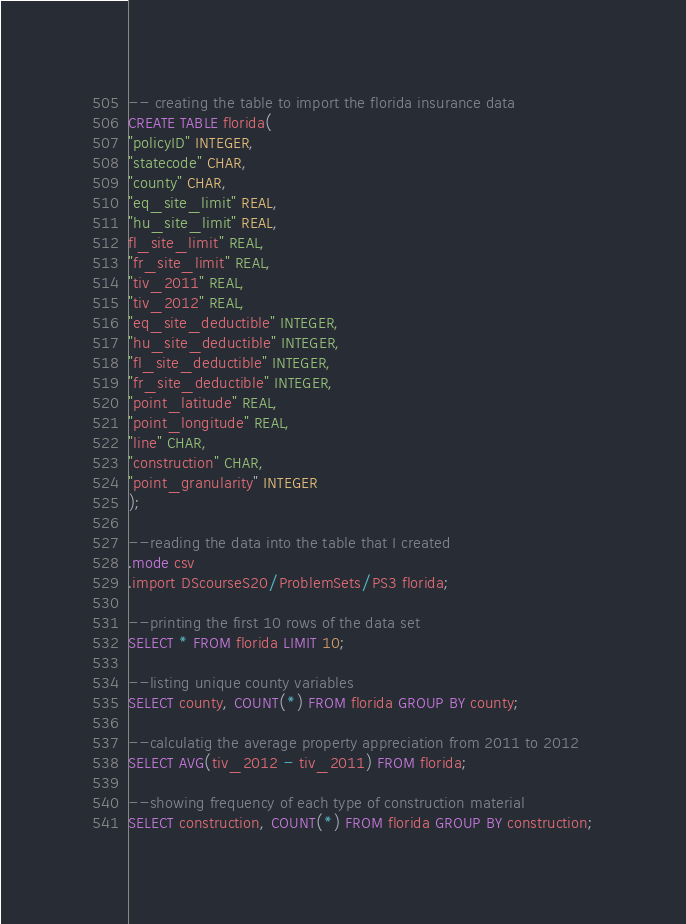<code> <loc_0><loc_0><loc_500><loc_500><_SQL_>-- creating the table to import the florida insurance data
CREATE TABLE florida(
"policyID" INTEGER,
"statecode" CHAR,
"county" CHAR,
"eq_site_limit" REAL,
"hu_site_limit" REAL,
fl_site_limit" REAL,
"fr_site_limit" REAL,
"tiv_2011" REAL,
"tiv_2012" REAL,
"eq_site_deductible" INTEGER,
"hu_site_deductible" INTEGER,
"fl_site_deductible" INTEGER,
"fr_site_deductible" INTEGER,
"point_latitude" REAL,
"point_longitude" REAL,
"line" CHAR,
"construction" CHAR,
"point_granularity" INTEGER
);

--reading the data into the table that I created
.mode csv
.import DScourseS20/ProblemSets/PS3 florida;

--printing the first 10 rows of the data set
SELECT * FROM florida LIMIT 10;

--listing unique county variables
SELECT county, COUNT(*) FROM florida GROUP BY county;

--calculatig the average property appreciation from 2011 to 2012
SELECT AVG(tiv_2012 - tiv_2011) FROM florida;

--showing frequency of each type of construction material
SELECT construction, COUNT(*) FROM florida GROUP BY construction;

</code> 